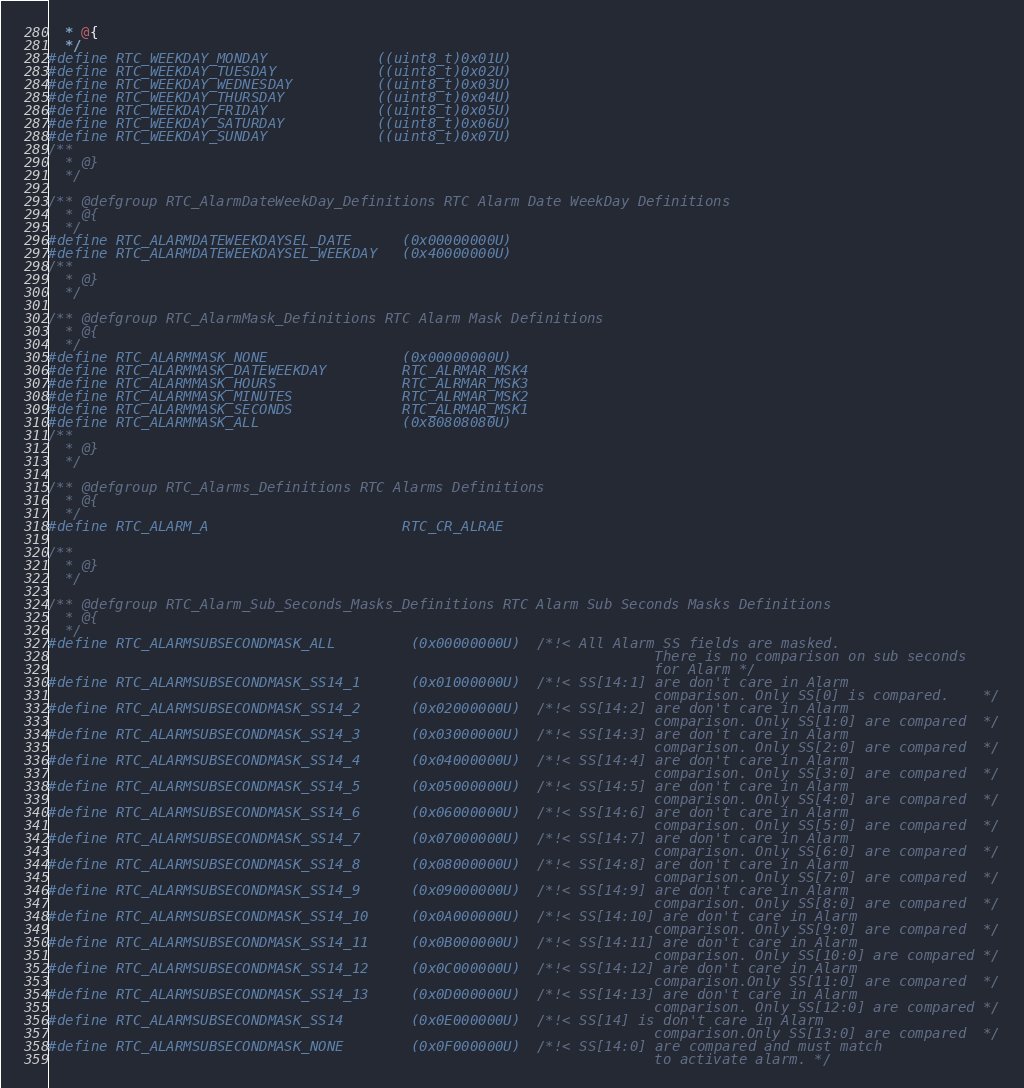Convert code to text. <code><loc_0><loc_0><loc_500><loc_500><_C_>  * @{
  */   
#define RTC_WEEKDAY_MONDAY             ((uint8_t)0x01U)
#define RTC_WEEKDAY_TUESDAY            ((uint8_t)0x02U)
#define RTC_WEEKDAY_WEDNESDAY          ((uint8_t)0x03U)
#define RTC_WEEKDAY_THURSDAY           ((uint8_t)0x04U)
#define RTC_WEEKDAY_FRIDAY             ((uint8_t)0x05U)
#define RTC_WEEKDAY_SATURDAY           ((uint8_t)0x06U)
#define RTC_WEEKDAY_SUNDAY             ((uint8_t)0x07U)
/**
  * @}
  */ 

/** @defgroup RTC_AlarmDateWeekDay_Definitions RTC Alarm Date WeekDay Definitions
  * @{
  */ 
#define RTC_ALARMDATEWEEKDAYSEL_DATE      (0x00000000U)
#define RTC_ALARMDATEWEEKDAYSEL_WEEKDAY   (0x40000000U)
/**
  * @}
  */ 

/** @defgroup RTC_AlarmMask_Definitions RTC Alarm Mask Definitions
  * @{
  */ 
#define RTC_ALARMMASK_NONE                (0x00000000U)
#define RTC_ALARMMASK_DATEWEEKDAY         RTC_ALRMAR_MSK4
#define RTC_ALARMMASK_HOURS               RTC_ALRMAR_MSK3
#define RTC_ALARMMASK_MINUTES             RTC_ALRMAR_MSK2
#define RTC_ALARMMASK_SECONDS             RTC_ALRMAR_MSK1
#define RTC_ALARMMASK_ALL                 (0x80808080U)
/**
  * @}
  */ 

/** @defgroup RTC_Alarms_Definitions RTC Alarms Definitions
  * @{
  */ 
#define RTC_ALARM_A                       RTC_CR_ALRAE

/**
  * @}
  */ 

/** @defgroup RTC_Alarm_Sub_Seconds_Masks_Definitions RTC Alarm Sub Seconds Masks Definitions
  * @{
  */ 
#define RTC_ALARMSUBSECONDMASK_ALL         (0x00000000U)  /*!< All Alarm SS fields are masked. 
                                                                        There is no comparison on sub seconds 
                                                                        for Alarm */
#define RTC_ALARMSUBSECONDMASK_SS14_1      (0x01000000U)  /*!< SS[14:1] are don't care in Alarm 
                                                                        comparison. Only SS[0] is compared.    */
#define RTC_ALARMSUBSECONDMASK_SS14_2      (0x02000000U)  /*!< SS[14:2] are don't care in Alarm 
                                                                        comparison. Only SS[1:0] are compared  */
#define RTC_ALARMSUBSECONDMASK_SS14_3      (0x03000000U)  /*!< SS[14:3] are don't care in Alarm 
                                                                        comparison. Only SS[2:0] are compared  */
#define RTC_ALARMSUBSECONDMASK_SS14_4      (0x04000000U)  /*!< SS[14:4] are don't care in Alarm 
                                                                        comparison. Only SS[3:0] are compared  */
#define RTC_ALARMSUBSECONDMASK_SS14_5      (0x05000000U)  /*!< SS[14:5] are don't care in Alarm 
                                                                        comparison. Only SS[4:0] are compared  */
#define RTC_ALARMSUBSECONDMASK_SS14_6      (0x06000000U)  /*!< SS[14:6] are don't care in Alarm 
                                                                        comparison. Only SS[5:0] are compared  */
#define RTC_ALARMSUBSECONDMASK_SS14_7      (0x07000000U)  /*!< SS[14:7] are don't care in Alarm 
                                                                        comparison. Only SS[6:0] are compared  */
#define RTC_ALARMSUBSECONDMASK_SS14_8      (0x08000000U)  /*!< SS[14:8] are don't care in Alarm 
                                                                        comparison. Only SS[7:0] are compared  */
#define RTC_ALARMSUBSECONDMASK_SS14_9      (0x09000000U)  /*!< SS[14:9] are don't care in Alarm 
                                                                        comparison. Only SS[8:0] are compared  */
#define RTC_ALARMSUBSECONDMASK_SS14_10     (0x0A000000U)  /*!< SS[14:10] are don't care in Alarm 
                                                                        comparison. Only SS[9:0] are compared  */
#define RTC_ALARMSUBSECONDMASK_SS14_11     (0x0B000000U)  /*!< SS[14:11] are don't care in Alarm 
                                                                        comparison. Only SS[10:0] are compared */
#define RTC_ALARMSUBSECONDMASK_SS14_12     (0x0C000000U)  /*!< SS[14:12] are don't care in Alarm 
                                                                        comparison.Only SS[11:0] are compared  */
#define RTC_ALARMSUBSECONDMASK_SS14_13     (0x0D000000U)  /*!< SS[14:13] are don't care in Alarm 
                                                                        comparison. Only SS[12:0] are compared */
#define RTC_ALARMSUBSECONDMASK_SS14        (0x0E000000U)  /*!< SS[14] is don't care in Alarm 
                                                                        comparison.Only SS[13:0] are compared  */
#define RTC_ALARMSUBSECONDMASK_NONE        (0x0F000000U)  /*!< SS[14:0] are compared and must match 
                                                                        to activate alarm. */</code> 